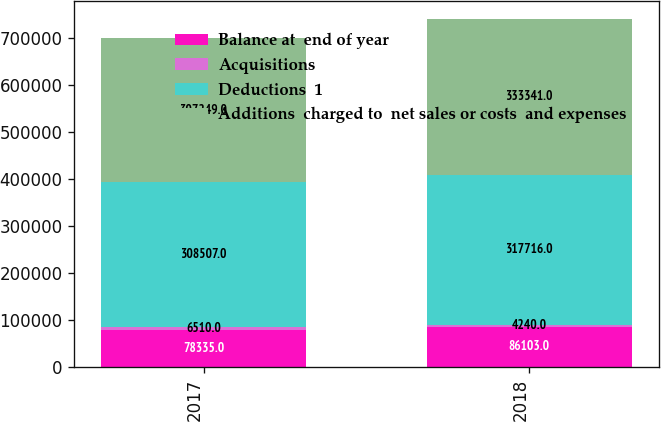Convert chart. <chart><loc_0><loc_0><loc_500><loc_500><stacked_bar_chart><ecel><fcel>2017<fcel>2018<nl><fcel>Balance at  end of year<fcel>78335<fcel>86103<nl><fcel>Acquisitions<fcel>6510<fcel>4240<nl><fcel>Deductions  1<fcel>308507<fcel>317716<nl><fcel>Additions  charged to  net sales or costs  and expenses<fcel>307249<fcel>333341<nl></chart> 